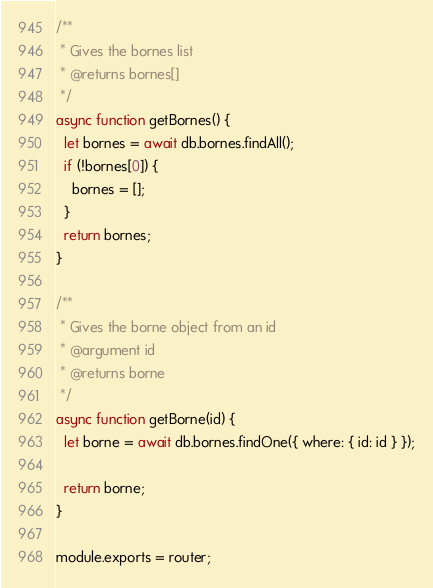<code> <loc_0><loc_0><loc_500><loc_500><_JavaScript_>
/**
 * Gives the bornes list
 * @returns bornes[]
 */
async function getBornes() {
  let bornes = await db.bornes.findAll();
  if (!bornes[0]) {
    bornes = [];
  }
  return bornes;
}

/**
 * Gives the borne object from an id
 * @argument id
 * @returns borne
 */
async function getBorne(id) {
  let borne = await db.bornes.findOne({ where: { id: id } });

  return borne;
}

module.exports = router;
</code> 